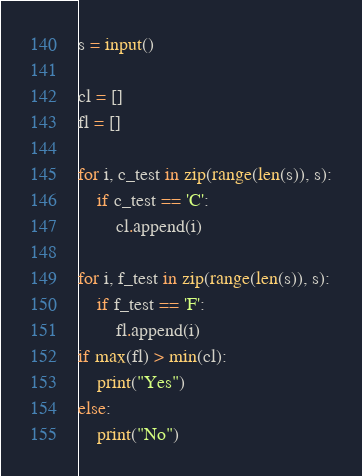Convert code to text. <code><loc_0><loc_0><loc_500><loc_500><_Python_>s = input()

cl = []
fl = []

for i, c_test in zip(range(len(s)), s):
    if c_test == 'C':
        cl.append(i)

for i, f_test in zip(range(len(s)), s):
    if f_test == 'F':
        fl.append(i)    
if max(fl) > min(cl):
    print("Yes")
else:
    print("No")</code> 